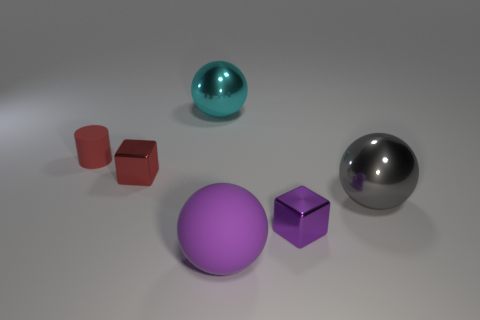Add 3 large cylinders. How many objects exist? 9 Subtract all blocks. How many objects are left? 4 Subtract all small red cylinders. Subtract all metal spheres. How many objects are left? 3 Add 2 cyan objects. How many cyan objects are left? 3 Add 4 small red metal blocks. How many small red metal blocks exist? 5 Subtract 0 yellow cylinders. How many objects are left? 6 